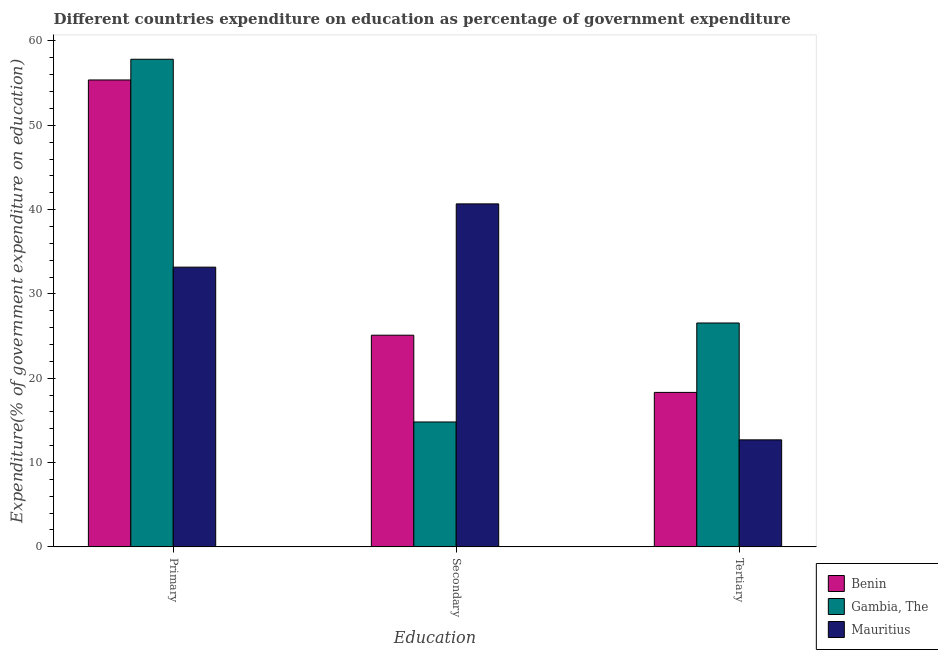How many groups of bars are there?
Keep it short and to the point. 3. Are the number of bars on each tick of the X-axis equal?
Provide a succinct answer. Yes. How many bars are there on the 3rd tick from the right?
Your answer should be very brief. 3. What is the label of the 3rd group of bars from the left?
Offer a very short reply. Tertiary. What is the expenditure on tertiary education in Gambia, The?
Make the answer very short. 26.55. Across all countries, what is the maximum expenditure on secondary education?
Offer a very short reply. 40.68. Across all countries, what is the minimum expenditure on secondary education?
Your answer should be very brief. 14.81. In which country was the expenditure on tertiary education maximum?
Offer a terse response. Gambia, The. In which country was the expenditure on tertiary education minimum?
Keep it short and to the point. Mauritius. What is the total expenditure on tertiary education in the graph?
Make the answer very short. 57.56. What is the difference between the expenditure on secondary education in Gambia, The and that in Mauritius?
Keep it short and to the point. -25.87. What is the difference between the expenditure on tertiary education in Benin and the expenditure on secondary education in Mauritius?
Provide a short and direct response. -22.36. What is the average expenditure on tertiary education per country?
Offer a very short reply. 19.19. What is the difference between the expenditure on tertiary education and expenditure on secondary education in Benin?
Provide a short and direct response. -6.78. What is the ratio of the expenditure on primary education in Gambia, The to that in Mauritius?
Offer a very short reply. 1.74. Is the difference between the expenditure on secondary education in Mauritius and Benin greater than the difference between the expenditure on tertiary education in Mauritius and Benin?
Keep it short and to the point. Yes. What is the difference between the highest and the second highest expenditure on tertiary education?
Your answer should be compact. 8.23. What is the difference between the highest and the lowest expenditure on tertiary education?
Make the answer very short. 13.86. In how many countries, is the expenditure on primary education greater than the average expenditure on primary education taken over all countries?
Your answer should be very brief. 2. Is the sum of the expenditure on primary education in Gambia, The and Mauritius greater than the maximum expenditure on tertiary education across all countries?
Provide a short and direct response. Yes. What does the 1st bar from the left in Tertiary represents?
Your answer should be very brief. Benin. What does the 3rd bar from the right in Tertiary represents?
Provide a succinct answer. Benin. Is it the case that in every country, the sum of the expenditure on primary education and expenditure on secondary education is greater than the expenditure on tertiary education?
Provide a succinct answer. Yes. How many countries are there in the graph?
Your response must be concise. 3. What is the difference between two consecutive major ticks on the Y-axis?
Provide a short and direct response. 10. Are the values on the major ticks of Y-axis written in scientific E-notation?
Offer a terse response. No. Where does the legend appear in the graph?
Make the answer very short. Bottom right. How many legend labels are there?
Your response must be concise. 3. How are the legend labels stacked?
Provide a succinct answer. Vertical. What is the title of the graph?
Make the answer very short. Different countries expenditure on education as percentage of government expenditure. What is the label or title of the X-axis?
Keep it short and to the point. Education. What is the label or title of the Y-axis?
Your answer should be compact. Expenditure(% of government expenditure on education). What is the Expenditure(% of government expenditure on education) of Benin in Primary?
Make the answer very short. 55.37. What is the Expenditure(% of government expenditure on education) of Gambia, The in Primary?
Make the answer very short. 57.83. What is the Expenditure(% of government expenditure on education) in Mauritius in Primary?
Your response must be concise. 33.17. What is the Expenditure(% of government expenditure on education) in Benin in Secondary?
Give a very brief answer. 25.1. What is the Expenditure(% of government expenditure on education) of Gambia, The in Secondary?
Ensure brevity in your answer.  14.81. What is the Expenditure(% of government expenditure on education) in Mauritius in Secondary?
Give a very brief answer. 40.68. What is the Expenditure(% of government expenditure on education) of Benin in Tertiary?
Keep it short and to the point. 18.32. What is the Expenditure(% of government expenditure on education) in Gambia, The in Tertiary?
Provide a succinct answer. 26.55. What is the Expenditure(% of government expenditure on education) in Mauritius in Tertiary?
Make the answer very short. 12.69. Across all Education, what is the maximum Expenditure(% of government expenditure on education) in Benin?
Provide a short and direct response. 55.37. Across all Education, what is the maximum Expenditure(% of government expenditure on education) in Gambia, The?
Keep it short and to the point. 57.83. Across all Education, what is the maximum Expenditure(% of government expenditure on education) in Mauritius?
Provide a short and direct response. 40.68. Across all Education, what is the minimum Expenditure(% of government expenditure on education) of Benin?
Make the answer very short. 18.32. Across all Education, what is the minimum Expenditure(% of government expenditure on education) in Gambia, The?
Your answer should be compact. 14.81. Across all Education, what is the minimum Expenditure(% of government expenditure on education) in Mauritius?
Your answer should be compact. 12.69. What is the total Expenditure(% of government expenditure on education) of Benin in the graph?
Give a very brief answer. 98.8. What is the total Expenditure(% of government expenditure on education) in Gambia, The in the graph?
Your answer should be compact. 99.19. What is the total Expenditure(% of government expenditure on education) in Mauritius in the graph?
Provide a short and direct response. 86.54. What is the difference between the Expenditure(% of government expenditure on education) of Benin in Primary and that in Secondary?
Offer a very short reply. 30.27. What is the difference between the Expenditure(% of government expenditure on education) in Gambia, The in Primary and that in Secondary?
Provide a short and direct response. 43.02. What is the difference between the Expenditure(% of government expenditure on education) of Mauritius in Primary and that in Secondary?
Provide a succinct answer. -7.5. What is the difference between the Expenditure(% of government expenditure on education) in Benin in Primary and that in Tertiary?
Offer a terse response. 37.05. What is the difference between the Expenditure(% of government expenditure on education) in Gambia, The in Primary and that in Tertiary?
Your answer should be compact. 31.28. What is the difference between the Expenditure(% of government expenditure on education) of Mauritius in Primary and that in Tertiary?
Provide a short and direct response. 20.48. What is the difference between the Expenditure(% of government expenditure on education) in Benin in Secondary and that in Tertiary?
Offer a terse response. 6.78. What is the difference between the Expenditure(% of government expenditure on education) in Gambia, The in Secondary and that in Tertiary?
Your response must be concise. -11.74. What is the difference between the Expenditure(% of government expenditure on education) of Mauritius in Secondary and that in Tertiary?
Offer a terse response. 27.99. What is the difference between the Expenditure(% of government expenditure on education) in Benin in Primary and the Expenditure(% of government expenditure on education) in Gambia, The in Secondary?
Provide a short and direct response. 40.56. What is the difference between the Expenditure(% of government expenditure on education) of Benin in Primary and the Expenditure(% of government expenditure on education) of Mauritius in Secondary?
Provide a short and direct response. 14.7. What is the difference between the Expenditure(% of government expenditure on education) of Gambia, The in Primary and the Expenditure(% of government expenditure on education) of Mauritius in Secondary?
Give a very brief answer. 17.15. What is the difference between the Expenditure(% of government expenditure on education) of Benin in Primary and the Expenditure(% of government expenditure on education) of Gambia, The in Tertiary?
Provide a short and direct response. 28.82. What is the difference between the Expenditure(% of government expenditure on education) of Benin in Primary and the Expenditure(% of government expenditure on education) of Mauritius in Tertiary?
Offer a very short reply. 42.68. What is the difference between the Expenditure(% of government expenditure on education) of Gambia, The in Primary and the Expenditure(% of government expenditure on education) of Mauritius in Tertiary?
Your answer should be very brief. 45.14. What is the difference between the Expenditure(% of government expenditure on education) in Benin in Secondary and the Expenditure(% of government expenditure on education) in Gambia, The in Tertiary?
Keep it short and to the point. -1.45. What is the difference between the Expenditure(% of government expenditure on education) of Benin in Secondary and the Expenditure(% of government expenditure on education) of Mauritius in Tertiary?
Keep it short and to the point. 12.41. What is the difference between the Expenditure(% of government expenditure on education) of Gambia, The in Secondary and the Expenditure(% of government expenditure on education) of Mauritius in Tertiary?
Keep it short and to the point. 2.12. What is the average Expenditure(% of government expenditure on education) of Benin per Education?
Make the answer very short. 32.93. What is the average Expenditure(% of government expenditure on education) in Gambia, The per Education?
Ensure brevity in your answer.  33.06. What is the average Expenditure(% of government expenditure on education) in Mauritius per Education?
Offer a terse response. 28.85. What is the difference between the Expenditure(% of government expenditure on education) of Benin and Expenditure(% of government expenditure on education) of Gambia, The in Primary?
Keep it short and to the point. -2.46. What is the difference between the Expenditure(% of government expenditure on education) in Benin and Expenditure(% of government expenditure on education) in Mauritius in Primary?
Your answer should be compact. 22.2. What is the difference between the Expenditure(% of government expenditure on education) in Gambia, The and Expenditure(% of government expenditure on education) in Mauritius in Primary?
Provide a succinct answer. 24.66. What is the difference between the Expenditure(% of government expenditure on education) of Benin and Expenditure(% of government expenditure on education) of Gambia, The in Secondary?
Ensure brevity in your answer.  10.29. What is the difference between the Expenditure(% of government expenditure on education) in Benin and Expenditure(% of government expenditure on education) in Mauritius in Secondary?
Your response must be concise. -15.57. What is the difference between the Expenditure(% of government expenditure on education) of Gambia, The and Expenditure(% of government expenditure on education) of Mauritius in Secondary?
Give a very brief answer. -25.87. What is the difference between the Expenditure(% of government expenditure on education) in Benin and Expenditure(% of government expenditure on education) in Gambia, The in Tertiary?
Your response must be concise. -8.23. What is the difference between the Expenditure(% of government expenditure on education) in Benin and Expenditure(% of government expenditure on education) in Mauritius in Tertiary?
Ensure brevity in your answer.  5.63. What is the difference between the Expenditure(% of government expenditure on education) of Gambia, The and Expenditure(% of government expenditure on education) of Mauritius in Tertiary?
Your answer should be very brief. 13.86. What is the ratio of the Expenditure(% of government expenditure on education) in Benin in Primary to that in Secondary?
Your answer should be very brief. 2.21. What is the ratio of the Expenditure(% of government expenditure on education) in Gambia, The in Primary to that in Secondary?
Your answer should be compact. 3.9. What is the ratio of the Expenditure(% of government expenditure on education) in Mauritius in Primary to that in Secondary?
Provide a short and direct response. 0.82. What is the ratio of the Expenditure(% of government expenditure on education) in Benin in Primary to that in Tertiary?
Offer a terse response. 3.02. What is the ratio of the Expenditure(% of government expenditure on education) in Gambia, The in Primary to that in Tertiary?
Ensure brevity in your answer.  2.18. What is the ratio of the Expenditure(% of government expenditure on education) of Mauritius in Primary to that in Tertiary?
Your response must be concise. 2.61. What is the ratio of the Expenditure(% of government expenditure on education) of Benin in Secondary to that in Tertiary?
Ensure brevity in your answer.  1.37. What is the ratio of the Expenditure(% of government expenditure on education) of Gambia, The in Secondary to that in Tertiary?
Your answer should be very brief. 0.56. What is the ratio of the Expenditure(% of government expenditure on education) in Mauritius in Secondary to that in Tertiary?
Your answer should be very brief. 3.21. What is the difference between the highest and the second highest Expenditure(% of government expenditure on education) of Benin?
Offer a very short reply. 30.27. What is the difference between the highest and the second highest Expenditure(% of government expenditure on education) of Gambia, The?
Give a very brief answer. 31.28. What is the difference between the highest and the second highest Expenditure(% of government expenditure on education) of Mauritius?
Your response must be concise. 7.5. What is the difference between the highest and the lowest Expenditure(% of government expenditure on education) of Benin?
Make the answer very short. 37.05. What is the difference between the highest and the lowest Expenditure(% of government expenditure on education) in Gambia, The?
Ensure brevity in your answer.  43.02. What is the difference between the highest and the lowest Expenditure(% of government expenditure on education) of Mauritius?
Offer a very short reply. 27.99. 